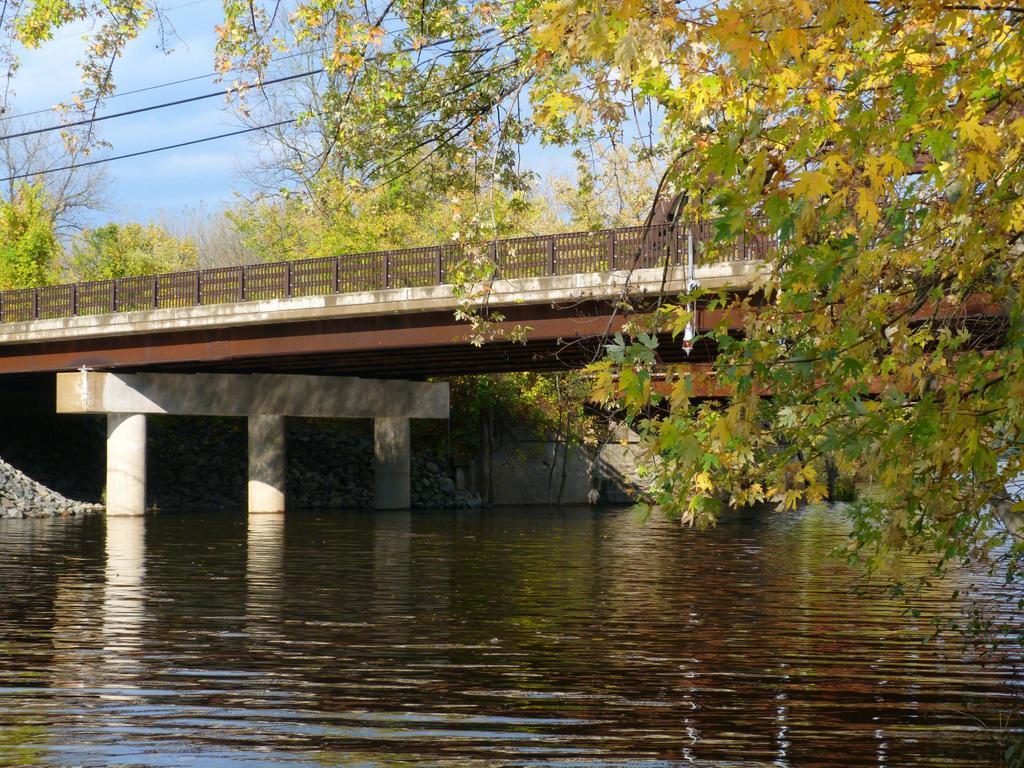Could you give a brief overview of what you see in this image? In this image I can see a water in the front and over it I can see a bridge. I can also see number of trees on the right side and in the background. On the top side of this image I can see few wires, clouds and the sky. 